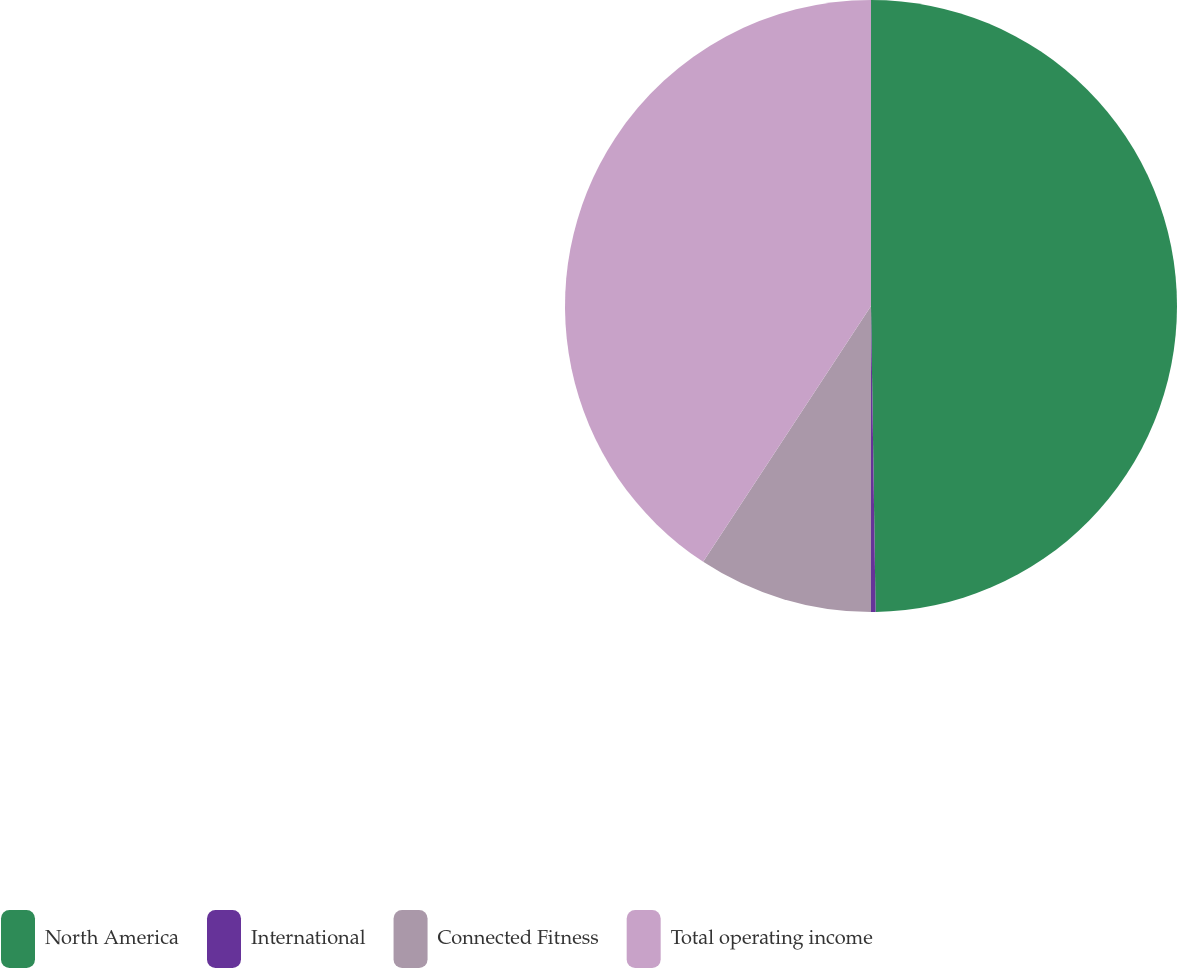<chart> <loc_0><loc_0><loc_500><loc_500><pie_chart><fcel>North America<fcel>International<fcel>Connected Fitness<fcel>Total operating income<nl><fcel>49.76%<fcel>0.24%<fcel>9.24%<fcel>40.76%<nl></chart> 